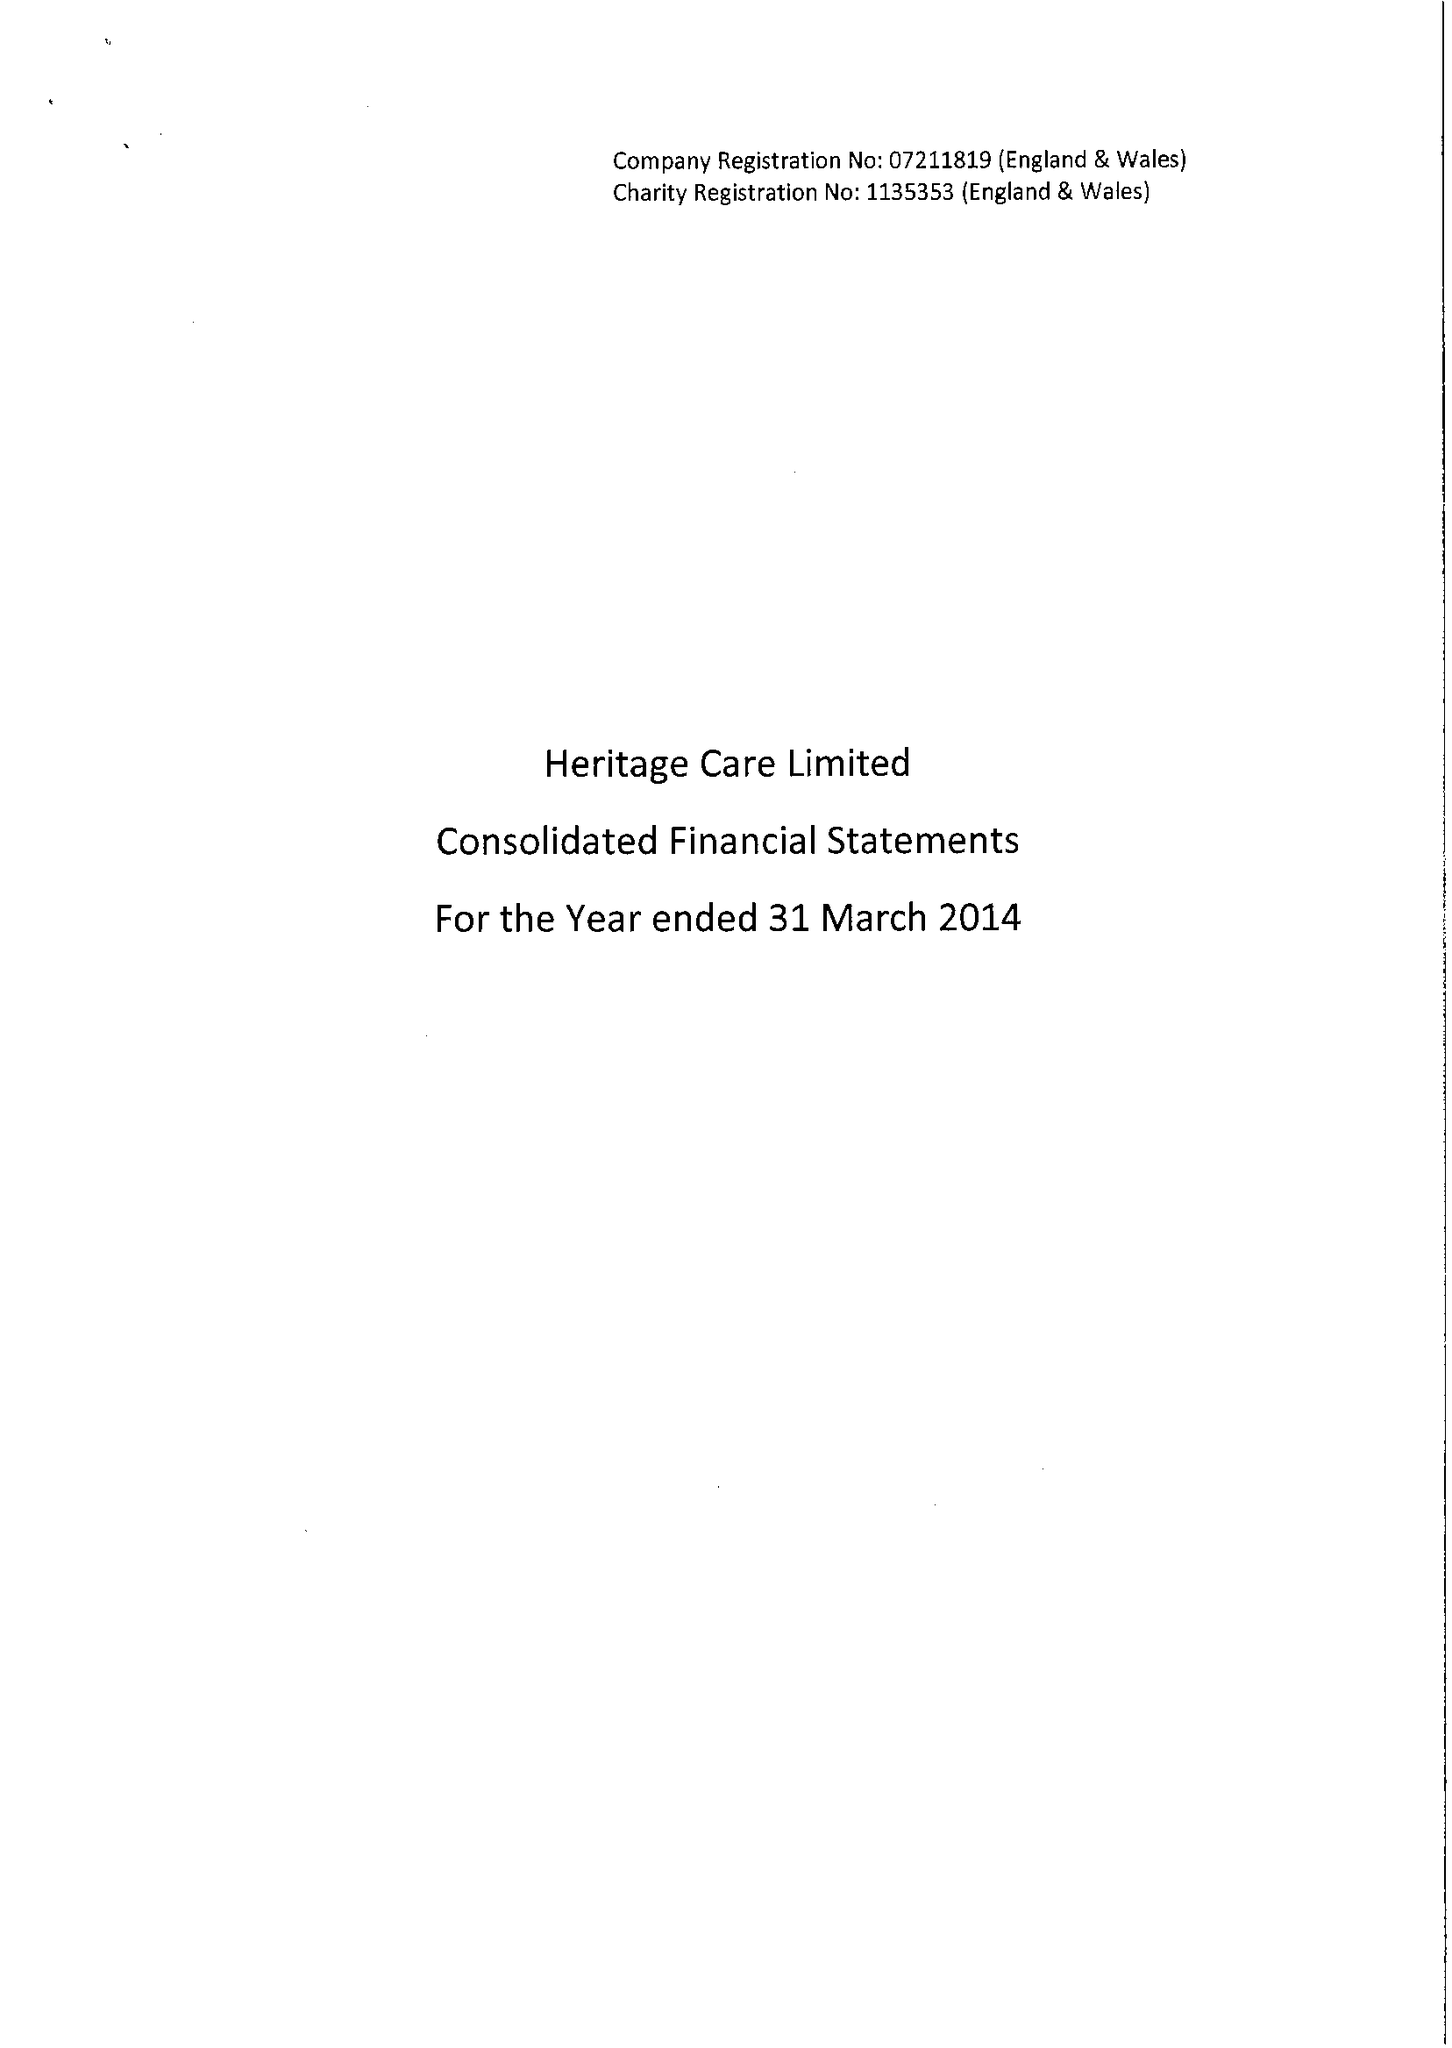What is the value for the charity_number?
Answer the question using a single word or phrase. 1135353 